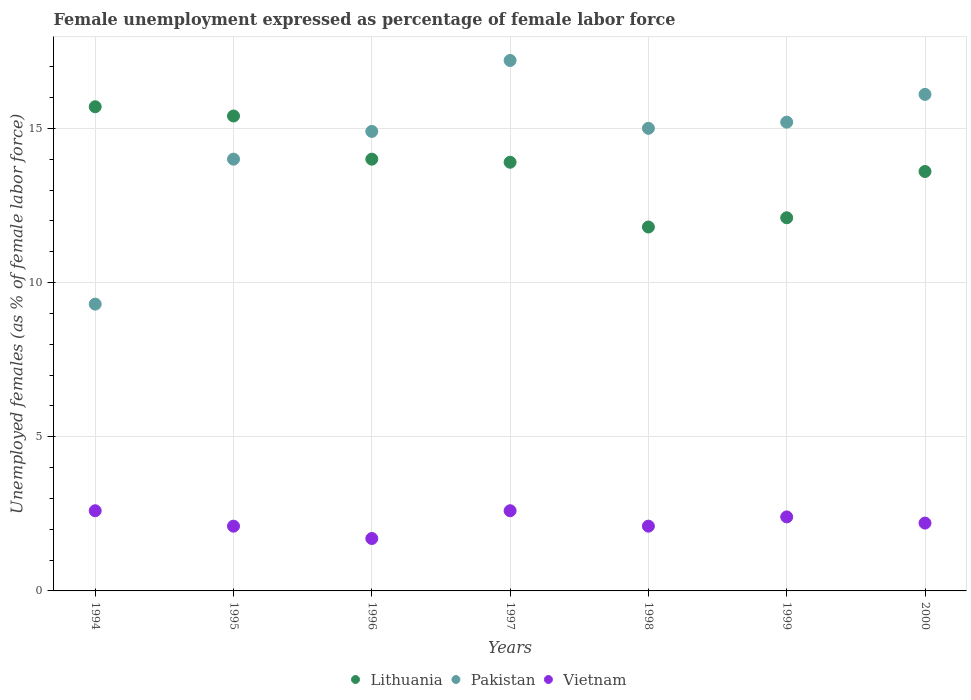Is the number of dotlines equal to the number of legend labels?
Ensure brevity in your answer.  Yes. What is the unemployment in females in in Vietnam in 1998?
Provide a short and direct response. 2.1. Across all years, what is the maximum unemployment in females in in Lithuania?
Ensure brevity in your answer.  15.7. Across all years, what is the minimum unemployment in females in in Vietnam?
Your response must be concise. 1.7. In which year was the unemployment in females in in Lithuania maximum?
Provide a short and direct response. 1994. What is the total unemployment in females in in Pakistan in the graph?
Offer a very short reply. 101.7. What is the difference between the unemployment in females in in Lithuania in 1994 and that in 1998?
Keep it short and to the point. 3.9. What is the difference between the unemployment in females in in Pakistan in 1998 and the unemployment in females in in Vietnam in 1997?
Keep it short and to the point. 12.4. What is the average unemployment in females in in Vietnam per year?
Your response must be concise. 2.24. In the year 1998, what is the difference between the unemployment in females in in Vietnam and unemployment in females in in Lithuania?
Provide a short and direct response. -9.7. What is the ratio of the unemployment in females in in Pakistan in 1995 to that in 1999?
Offer a very short reply. 0.92. Is the unemployment in females in in Pakistan in 1995 less than that in 1998?
Make the answer very short. Yes. Is the difference between the unemployment in females in in Vietnam in 1995 and 1996 greater than the difference between the unemployment in females in in Lithuania in 1995 and 1996?
Provide a succinct answer. No. What is the difference between the highest and the second highest unemployment in females in in Pakistan?
Offer a terse response. 1.1. What is the difference between the highest and the lowest unemployment in females in in Pakistan?
Make the answer very short. 7.9. Is the unemployment in females in in Vietnam strictly greater than the unemployment in females in in Pakistan over the years?
Provide a short and direct response. No. Is the unemployment in females in in Lithuania strictly less than the unemployment in females in in Vietnam over the years?
Offer a very short reply. No. How many dotlines are there?
Make the answer very short. 3. What is the difference between two consecutive major ticks on the Y-axis?
Keep it short and to the point. 5. How many legend labels are there?
Give a very brief answer. 3. What is the title of the graph?
Provide a short and direct response. Female unemployment expressed as percentage of female labor force. Does "Chile" appear as one of the legend labels in the graph?
Give a very brief answer. No. What is the label or title of the Y-axis?
Provide a short and direct response. Unemployed females (as % of female labor force). What is the Unemployed females (as % of female labor force) in Lithuania in 1994?
Provide a short and direct response. 15.7. What is the Unemployed females (as % of female labor force) of Pakistan in 1994?
Make the answer very short. 9.3. What is the Unemployed females (as % of female labor force) in Vietnam in 1994?
Offer a very short reply. 2.6. What is the Unemployed females (as % of female labor force) in Lithuania in 1995?
Provide a succinct answer. 15.4. What is the Unemployed females (as % of female labor force) of Pakistan in 1995?
Keep it short and to the point. 14. What is the Unemployed females (as % of female labor force) of Vietnam in 1995?
Ensure brevity in your answer.  2.1. What is the Unemployed females (as % of female labor force) of Lithuania in 1996?
Offer a terse response. 14. What is the Unemployed females (as % of female labor force) in Pakistan in 1996?
Your answer should be compact. 14.9. What is the Unemployed females (as % of female labor force) in Vietnam in 1996?
Your response must be concise. 1.7. What is the Unemployed females (as % of female labor force) in Lithuania in 1997?
Your response must be concise. 13.9. What is the Unemployed females (as % of female labor force) in Pakistan in 1997?
Offer a terse response. 17.2. What is the Unemployed females (as % of female labor force) of Vietnam in 1997?
Provide a short and direct response. 2.6. What is the Unemployed females (as % of female labor force) of Lithuania in 1998?
Offer a very short reply. 11.8. What is the Unemployed females (as % of female labor force) of Pakistan in 1998?
Offer a very short reply. 15. What is the Unemployed females (as % of female labor force) in Vietnam in 1998?
Your answer should be compact. 2.1. What is the Unemployed females (as % of female labor force) of Lithuania in 1999?
Your answer should be very brief. 12.1. What is the Unemployed females (as % of female labor force) in Pakistan in 1999?
Keep it short and to the point. 15.2. What is the Unemployed females (as % of female labor force) of Vietnam in 1999?
Give a very brief answer. 2.4. What is the Unemployed females (as % of female labor force) in Lithuania in 2000?
Offer a terse response. 13.6. What is the Unemployed females (as % of female labor force) of Pakistan in 2000?
Offer a terse response. 16.1. What is the Unemployed females (as % of female labor force) of Vietnam in 2000?
Provide a succinct answer. 2.2. Across all years, what is the maximum Unemployed females (as % of female labor force) of Lithuania?
Offer a terse response. 15.7. Across all years, what is the maximum Unemployed females (as % of female labor force) of Pakistan?
Provide a short and direct response. 17.2. Across all years, what is the maximum Unemployed females (as % of female labor force) of Vietnam?
Ensure brevity in your answer.  2.6. Across all years, what is the minimum Unemployed females (as % of female labor force) of Lithuania?
Your answer should be very brief. 11.8. Across all years, what is the minimum Unemployed females (as % of female labor force) in Pakistan?
Your response must be concise. 9.3. Across all years, what is the minimum Unemployed females (as % of female labor force) in Vietnam?
Make the answer very short. 1.7. What is the total Unemployed females (as % of female labor force) in Lithuania in the graph?
Provide a succinct answer. 96.5. What is the total Unemployed females (as % of female labor force) of Pakistan in the graph?
Offer a very short reply. 101.7. What is the difference between the Unemployed females (as % of female labor force) in Pakistan in 1994 and that in 1995?
Offer a terse response. -4.7. What is the difference between the Unemployed females (as % of female labor force) in Vietnam in 1994 and that in 1995?
Give a very brief answer. 0.5. What is the difference between the Unemployed females (as % of female labor force) in Pakistan in 1994 and that in 1996?
Provide a succinct answer. -5.6. What is the difference between the Unemployed females (as % of female labor force) in Vietnam in 1994 and that in 1996?
Your answer should be very brief. 0.9. What is the difference between the Unemployed females (as % of female labor force) in Pakistan in 1994 and that in 1997?
Your answer should be compact. -7.9. What is the difference between the Unemployed females (as % of female labor force) of Vietnam in 1994 and that in 1997?
Your answer should be compact. 0. What is the difference between the Unemployed females (as % of female labor force) of Pakistan in 1994 and that in 1998?
Make the answer very short. -5.7. What is the difference between the Unemployed females (as % of female labor force) in Vietnam in 1994 and that in 1998?
Your answer should be compact. 0.5. What is the difference between the Unemployed females (as % of female labor force) of Lithuania in 1994 and that in 1999?
Give a very brief answer. 3.6. What is the difference between the Unemployed females (as % of female labor force) in Vietnam in 1994 and that in 1999?
Keep it short and to the point. 0.2. What is the difference between the Unemployed females (as % of female labor force) of Lithuania in 1994 and that in 2000?
Offer a very short reply. 2.1. What is the difference between the Unemployed females (as % of female labor force) in Pakistan in 1994 and that in 2000?
Give a very brief answer. -6.8. What is the difference between the Unemployed females (as % of female labor force) of Lithuania in 1995 and that in 1996?
Your response must be concise. 1.4. What is the difference between the Unemployed females (as % of female labor force) in Lithuania in 1995 and that in 1997?
Offer a terse response. 1.5. What is the difference between the Unemployed females (as % of female labor force) in Pakistan in 1995 and that in 1997?
Offer a very short reply. -3.2. What is the difference between the Unemployed females (as % of female labor force) of Lithuania in 1995 and that in 1999?
Offer a very short reply. 3.3. What is the difference between the Unemployed females (as % of female labor force) in Vietnam in 1995 and that in 1999?
Offer a very short reply. -0.3. What is the difference between the Unemployed females (as % of female labor force) in Lithuania in 1995 and that in 2000?
Offer a terse response. 1.8. What is the difference between the Unemployed females (as % of female labor force) of Lithuania in 1996 and that in 1997?
Keep it short and to the point. 0.1. What is the difference between the Unemployed females (as % of female labor force) of Vietnam in 1996 and that in 1997?
Your answer should be compact. -0.9. What is the difference between the Unemployed females (as % of female labor force) in Lithuania in 1996 and that in 1998?
Your response must be concise. 2.2. What is the difference between the Unemployed females (as % of female labor force) in Pakistan in 1996 and that in 1998?
Provide a short and direct response. -0.1. What is the difference between the Unemployed females (as % of female labor force) of Vietnam in 1996 and that in 1998?
Provide a short and direct response. -0.4. What is the difference between the Unemployed females (as % of female labor force) of Lithuania in 1996 and that in 1999?
Make the answer very short. 1.9. What is the difference between the Unemployed females (as % of female labor force) of Vietnam in 1996 and that in 1999?
Keep it short and to the point. -0.7. What is the difference between the Unemployed females (as % of female labor force) in Lithuania in 1996 and that in 2000?
Provide a short and direct response. 0.4. What is the difference between the Unemployed females (as % of female labor force) of Pakistan in 1996 and that in 2000?
Give a very brief answer. -1.2. What is the difference between the Unemployed females (as % of female labor force) of Vietnam in 1996 and that in 2000?
Your response must be concise. -0.5. What is the difference between the Unemployed females (as % of female labor force) of Pakistan in 1997 and that in 1998?
Offer a very short reply. 2.2. What is the difference between the Unemployed females (as % of female labor force) of Pakistan in 1997 and that in 1999?
Offer a terse response. 2. What is the difference between the Unemployed females (as % of female labor force) in Lithuania in 1997 and that in 2000?
Provide a succinct answer. 0.3. What is the difference between the Unemployed females (as % of female labor force) of Lithuania in 1998 and that in 1999?
Your answer should be very brief. -0.3. What is the difference between the Unemployed females (as % of female labor force) in Pakistan in 1998 and that in 1999?
Provide a succinct answer. -0.2. What is the difference between the Unemployed females (as % of female labor force) of Vietnam in 1998 and that in 1999?
Provide a succinct answer. -0.3. What is the difference between the Unemployed females (as % of female labor force) in Lithuania in 1998 and that in 2000?
Offer a very short reply. -1.8. What is the difference between the Unemployed females (as % of female labor force) in Pakistan in 1998 and that in 2000?
Keep it short and to the point. -1.1. What is the difference between the Unemployed females (as % of female labor force) in Vietnam in 1998 and that in 2000?
Offer a very short reply. -0.1. What is the difference between the Unemployed females (as % of female labor force) of Lithuania in 1999 and that in 2000?
Keep it short and to the point. -1.5. What is the difference between the Unemployed females (as % of female labor force) in Pakistan in 1999 and that in 2000?
Keep it short and to the point. -0.9. What is the difference between the Unemployed females (as % of female labor force) in Lithuania in 1994 and the Unemployed females (as % of female labor force) in Pakistan in 1995?
Your answer should be very brief. 1.7. What is the difference between the Unemployed females (as % of female labor force) in Lithuania in 1994 and the Unemployed females (as % of female labor force) in Pakistan in 1996?
Offer a terse response. 0.8. What is the difference between the Unemployed females (as % of female labor force) of Lithuania in 1994 and the Unemployed females (as % of female labor force) of Vietnam in 1997?
Your answer should be compact. 13.1. What is the difference between the Unemployed females (as % of female labor force) of Lithuania in 1994 and the Unemployed females (as % of female labor force) of Vietnam in 1998?
Provide a short and direct response. 13.6. What is the difference between the Unemployed females (as % of female labor force) in Pakistan in 1994 and the Unemployed females (as % of female labor force) in Vietnam in 1998?
Give a very brief answer. 7.2. What is the difference between the Unemployed females (as % of female labor force) in Lithuania in 1994 and the Unemployed females (as % of female labor force) in Pakistan in 1999?
Make the answer very short. 0.5. What is the difference between the Unemployed females (as % of female labor force) of Lithuania in 1994 and the Unemployed females (as % of female labor force) of Vietnam in 1999?
Provide a short and direct response. 13.3. What is the difference between the Unemployed females (as % of female labor force) in Lithuania in 1995 and the Unemployed females (as % of female labor force) in Pakistan in 1996?
Provide a short and direct response. 0.5. What is the difference between the Unemployed females (as % of female labor force) of Pakistan in 1995 and the Unemployed females (as % of female labor force) of Vietnam in 1996?
Your answer should be compact. 12.3. What is the difference between the Unemployed females (as % of female labor force) of Pakistan in 1995 and the Unemployed females (as % of female labor force) of Vietnam in 1997?
Offer a very short reply. 11.4. What is the difference between the Unemployed females (as % of female labor force) in Lithuania in 1995 and the Unemployed females (as % of female labor force) in Vietnam in 1998?
Offer a very short reply. 13.3. What is the difference between the Unemployed females (as % of female labor force) in Lithuania in 1995 and the Unemployed females (as % of female labor force) in Vietnam in 1999?
Provide a succinct answer. 13. What is the difference between the Unemployed females (as % of female labor force) in Pakistan in 1995 and the Unemployed females (as % of female labor force) in Vietnam in 1999?
Ensure brevity in your answer.  11.6. What is the difference between the Unemployed females (as % of female labor force) in Lithuania in 1995 and the Unemployed females (as % of female labor force) in Pakistan in 2000?
Keep it short and to the point. -0.7. What is the difference between the Unemployed females (as % of female labor force) of Lithuania in 1995 and the Unemployed females (as % of female labor force) of Vietnam in 2000?
Offer a terse response. 13.2. What is the difference between the Unemployed females (as % of female labor force) of Pakistan in 1995 and the Unemployed females (as % of female labor force) of Vietnam in 2000?
Give a very brief answer. 11.8. What is the difference between the Unemployed females (as % of female labor force) of Lithuania in 1996 and the Unemployed females (as % of female labor force) of Pakistan in 1997?
Ensure brevity in your answer.  -3.2. What is the difference between the Unemployed females (as % of female labor force) in Pakistan in 1996 and the Unemployed females (as % of female labor force) in Vietnam in 1997?
Keep it short and to the point. 12.3. What is the difference between the Unemployed females (as % of female labor force) in Lithuania in 1996 and the Unemployed females (as % of female labor force) in Pakistan in 1998?
Keep it short and to the point. -1. What is the difference between the Unemployed females (as % of female labor force) of Lithuania in 1996 and the Unemployed females (as % of female labor force) of Vietnam in 1998?
Your response must be concise. 11.9. What is the difference between the Unemployed females (as % of female labor force) in Lithuania in 1996 and the Unemployed females (as % of female labor force) in Pakistan in 1999?
Your response must be concise. -1.2. What is the difference between the Unemployed females (as % of female labor force) in Lithuania in 1996 and the Unemployed females (as % of female labor force) in Vietnam in 1999?
Your response must be concise. 11.6. What is the difference between the Unemployed females (as % of female labor force) of Lithuania in 1996 and the Unemployed females (as % of female labor force) of Vietnam in 2000?
Offer a terse response. 11.8. What is the difference between the Unemployed females (as % of female labor force) in Pakistan in 1996 and the Unemployed females (as % of female labor force) in Vietnam in 2000?
Your response must be concise. 12.7. What is the difference between the Unemployed females (as % of female labor force) in Lithuania in 1997 and the Unemployed females (as % of female labor force) in Pakistan in 1998?
Give a very brief answer. -1.1. What is the difference between the Unemployed females (as % of female labor force) of Pakistan in 1997 and the Unemployed females (as % of female labor force) of Vietnam in 1998?
Provide a succinct answer. 15.1. What is the difference between the Unemployed females (as % of female labor force) in Lithuania in 1997 and the Unemployed females (as % of female labor force) in Vietnam in 1999?
Offer a very short reply. 11.5. What is the difference between the Unemployed females (as % of female labor force) of Lithuania in 1997 and the Unemployed females (as % of female labor force) of Pakistan in 2000?
Give a very brief answer. -2.2. What is the difference between the Unemployed females (as % of female labor force) of Lithuania in 1998 and the Unemployed females (as % of female labor force) of Pakistan in 1999?
Give a very brief answer. -3.4. What is the difference between the Unemployed females (as % of female labor force) in Pakistan in 1998 and the Unemployed females (as % of female labor force) in Vietnam in 1999?
Keep it short and to the point. 12.6. What is the difference between the Unemployed females (as % of female labor force) of Lithuania in 1998 and the Unemployed females (as % of female labor force) of Pakistan in 2000?
Make the answer very short. -4.3. What is the difference between the Unemployed females (as % of female labor force) in Pakistan in 1998 and the Unemployed females (as % of female labor force) in Vietnam in 2000?
Make the answer very short. 12.8. What is the difference between the Unemployed females (as % of female labor force) of Lithuania in 1999 and the Unemployed females (as % of female labor force) of Pakistan in 2000?
Offer a very short reply. -4. What is the average Unemployed females (as % of female labor force) in Lithuania per year?
Keep it short and to the point. 13.79. What is the average Unemployed females (as % of female labor force) of Pakistan per year?
Your answer should be very brief. 14.53. What is the average Unemployed females (as % of female labor force) of Vietnam per year?
Your answer should be compact. 2.24. In the year 1995, what is the difference between the Unemployed females (as % of female labor force) in Pakistan and Unemployed females (as % of female labor force) in Vietnam?
Make the answer very short. 11.9. In the year 1996, what is the difference between the Unemployed females (as % of female labor force) in Lithuania and Unemployed females (as % of female labor force) in Vietnam?
Offer a very short reply. 12.3. In the year 1997, what is the difference between the Unemployed females (as % of female labor force) of Lithuania and Unemployed females (as % of female labor force) of Vietnam?
Provide a succinct answer. 11.3. In the year 1997, what is the difference between the Unemployed females (as % of female labor force) of Pakistan and Unemployed females (as % of female labor force) of Vietnam?
Make the answer very short. 14.6. In the year 1998, what is the difference between the Unemployed females (as % of female labor force) in Lithuania and Unemployed females (as % of female labor force) in Pakistan?
Give a very brief answer. -3.2. In the year 1999, what is the difference between the Unemployed females (as % of female labor force) of Pakistan and Unemployed females (as % of female labor force) of Vietnam?
Provide a succinct answer. 12.8. In the year 2000, what is the difference between the Unemployed females (as % of female labor force) in Lithuania and Unemployed females (as % of female labor force) in Vietnam?
Offer a very short reply. 11.4. What is the ratio of the Unemployed females (as % of female labor force) of Lithuania in 1994 to that in 1995?
Ensure brevity in your answer.  1.02. What is the ratio of the Unemployed females (as % of female labor force) of Pakistan in 1994 to that in 1995?
Ensure brevity in your answer.  0.66. What is the ratio of the Unemployed females (as % of female labor force) of Vietnam in 1994 to that in 1995?
Provide a short and direct response. 1.24. What is the ratio of the Unemployed females (as % of female labor force) in Lithuania in 1994 to that in 1996?
Give a very brief answer. 1.12. What is the ratio of the Unemployed females (as % of female labor force) of Pakistan in 1994 to that in 1996?
Make the answer very short. 0.62. What is the ratio of the Unemployed females (as % of female labor force) in Vietnam in 1994 to that in 1996?
Provide a short and direct response. 1.53. What is the ratio of the Unemployed females (as % of female labor force) in Lithuania in 1994 to that in 1997?
Offer a terse response. 1.13. What is the ratio of the Unemployed females (as % of female labor force) in Pakistan in 1994 to that in 1997?
Your answer should be very brief. 0.54. What is the ratio of the Unemployed females (as % of female labor force) of Lithuania in 1994 to that in 1998?
Your answer should be very brief. 1.33. What is the ratio of the Unemployed females (as % of female labor force) in Pakistan in 1994 to that in 1998?
Offer a terse response. 0.62. What is the ratio of the Unemployed females (as % of female labor force) of Vietnam in 1994 to that in 1998?
Your response must be concise. 1.24. What is the ratio of the Unemployed females (as % of female labor force) in Lithuania in 1994 to that in 1999?
Give a very brief answer. 1.3. What is the ratio of the Unemployed females (as % of female labor force) of Pakistan in 1994 to that in 1999?
Keep it short and to the point. 0.61. What is the ratio of the Unemployed females (as % of female labor force) in Lithuania in 1994 to that in 2000?
Offer a terse response. 1.15. What is the ratio of the Unemployed females (as % of female labor force) in Pakistan in 1994 to that in 2000?
Provide a short and direct response. 0.58. What is the ratio of the Unemployed females (as % of female labor force) in Vietnam in 1994 to that in 2000?
Ensure brevity in your answer.  1.18. What is the ratio of the Unemployed females (as % of female labor force) of Pakistan in 1995 to that in 1996?
Offer a very short reply. 0.94. What is the ratio of the Unemployed females (as % of female labor force) in Vietnam in 1995 to that in 1996?
Give a very brief answer. 1.24. What is the ratio of the Unemployed females (as % of female labor force) of Lithuania in 1995 to that in 1997?
Make the answer very short. 1.11. What is the ratio of the Unemployed females (as % of female labor force) of Pakistan in 1995 to that in 1997?
Provide a short and direct response. 0.81. What is the ratio of the Unemployed females (as % of female labor force) of Vietnam in 1995 to that in 1997?
Keep it short and to the point. 0.81. What is the ratio of the Unemployed females (as % of female labor force) of Lithuania in 1995 to that in 1998?
Give a very brief answer. 1.31. What is the ratio of the Unemployed females (as % of female labor force) of Lithuania in 1995 to that in 1999?
Ensure brevity in your answer.  1.27. What is the ratio of the Unemployed females (as % of female labor force) in Pakistan in 1995 to that in 1999?
Give a very brief answer. 0.92. What is the ratio of the Unemployed females (as % of female labor force) in Vietnam in 1995 to that in 1999?
Keep it short and to the point. 0.88. What is the ratio of the Unemployed females (as % of female labor force) in Lithuania in 1995 to that in 2000?
Keep it short and to the point. 1.13. What is the ratio of the Unemployed females (as % of female labor force) of Pakistan in 1995 to that in 2000?
Keep it short and to the point. 0.87. What is the ratio of the Unemployed females (as % of female labor force) in Vietnam in 1995 to that in 2000?
Your answer should be compact. 0.95. What is the ratio of the Unemployed females (as % of female labor force) in Lithuania in 1996 to that in 1997?
Give a very brief answer. 1.01. What is the ratio of the Unemployed females (as % of female labor force) of Pakistan in 1996 to that in 1997?
Your answer should be compact. 0.87. What is the ratio of the Unemployed females (as % of female labor force) of Vietnam in 1996 to that in 1997?
Your response must be concise. 0.65. What is the ratio of the Unemployed females (as % of female labor force) of Lithuania in 1996 to that in 1998?
Your answer should be very brief. 1.19. What is the ratio of the Unemployed females (as % of female labor force) of Pakistan in 1996 to that in 1998?
Offer a very short reply. 0.99. What is the ratio of the Unemployed females (as % of female labor force) of Vietnam in 1996 to that in 1998?
Keep it short and to the point. 0.81. What is the ratio of the Unemployed females (as % of female labor force) in Lithuania in 1996 to that in 1999?
Give a very brief answer. 1.16. What is the ratio of the Unemployed females (as % of female labor force) in Pakistan in 1996 to that in 1999?
Give a very brief answer. 0.98. What is the ratio of the Unemployed females (as % of female labor force) of Vietnam in 1996 to that in 1999?
Offer a terse response. 0.71. What is the ratio of the Unemployed females (as % of female labor force) in Lithuania in 1996 to that in 2000?
Keep it short and to the point. 1.03. What is the ratio of the Unemployed females (as % of female labor force) in Pakistan in 1996 to that in 2000?
Offer a terse response. 0.93. What is the ratio of the Unemployed females (as % of female labor force) in Vietnam in 1996 to that in 2000?
Give a very brief answer. 0.77. What is the ratio of the Unemployed females (as % of female labor force) in Lithuania in 1997 to that in 1998?
Keep it short and to the point. 1.18. What is the ratio of the Unemployed females (as % of female labor force) of Pakistan in 1997 to that in 1998?
Your answer should be very brief. 1.15. What is the ratio of the Unemployed females (as % of female labor force) in Vietnam in 1997 to that in 1998?
Provide a short and direct response. 1.24. What is the ratio of the Unemployed females (as % of female labor force) in Lithuania in 1997 to that in 1999?
Your answer should be compact. 1.15. What is the ratio of the Unemployed females (as % of female labor force) in Pakistan in 1997 to that in 1999?
Give a very brief answer. 1.13. What is the ratio of the Unemployed females (as % of female labor force) of Lithuania in 1997 to that in 2000?
Your answer should be compact. 1.02. What is the ratio of the Unemployed females (as % of female labor force) of Pakistan in 1997 to that in 2000?
Give a very brief answer. 1.07. What is the ratio of the Unemployed females (as % of female labor force) in Vietnam in 1997 to that in 2000?
Your answer should be very brief. 1.18. What is the ratio of the Unemployed females (as % of female labor force) of Lithuania in 1998 to that in 1999?
Ensure brevity in your answer.  0.98. What is the ratio of the Unemployed females (as % of female labor force) in Lithuania in 1998 to that in 2000?
Ensure brevity in your answer.  0.87. What is the ratio of the Unemployed females (as % of female labor force) of Pakistan in 1998 to that in 2000?
Provide a succinct answer. 0.93. What is the ratio of the Unemployed females (as % of female labor force) in Vietnam in 1998 to that in 2000?
Provide a succinct answer. 0.95. What is the ratio of the Unemployed females (as % of female labor force) of Lithuania in 1999 to that in 2000?
Give a very brief answer. 0.89. What is the ratio of the Unemployed females (as % of female labor force) of Pakistan in 1999 to that in 2000?
Give a very brief answer. 0.94. What is the difference between the highest and the second highest Unemployed females (as % of female labor force) in Lithuania?
Your response must be concise. 0.3. What is the difference between the highest and the second highest Unemployed females (as % of female labor force) in Pakistan?
Keep it short and to the point. 1.1. What is the difference between the highest and the second highest Unemployed females (as % of female labor force) in Vietnam?
Provide a short and direct response. 0. What is the difference between the highest and the lowest Unemployed females (as % of female labor force) in Lithuania?
Make the answer very short. 3.9. 